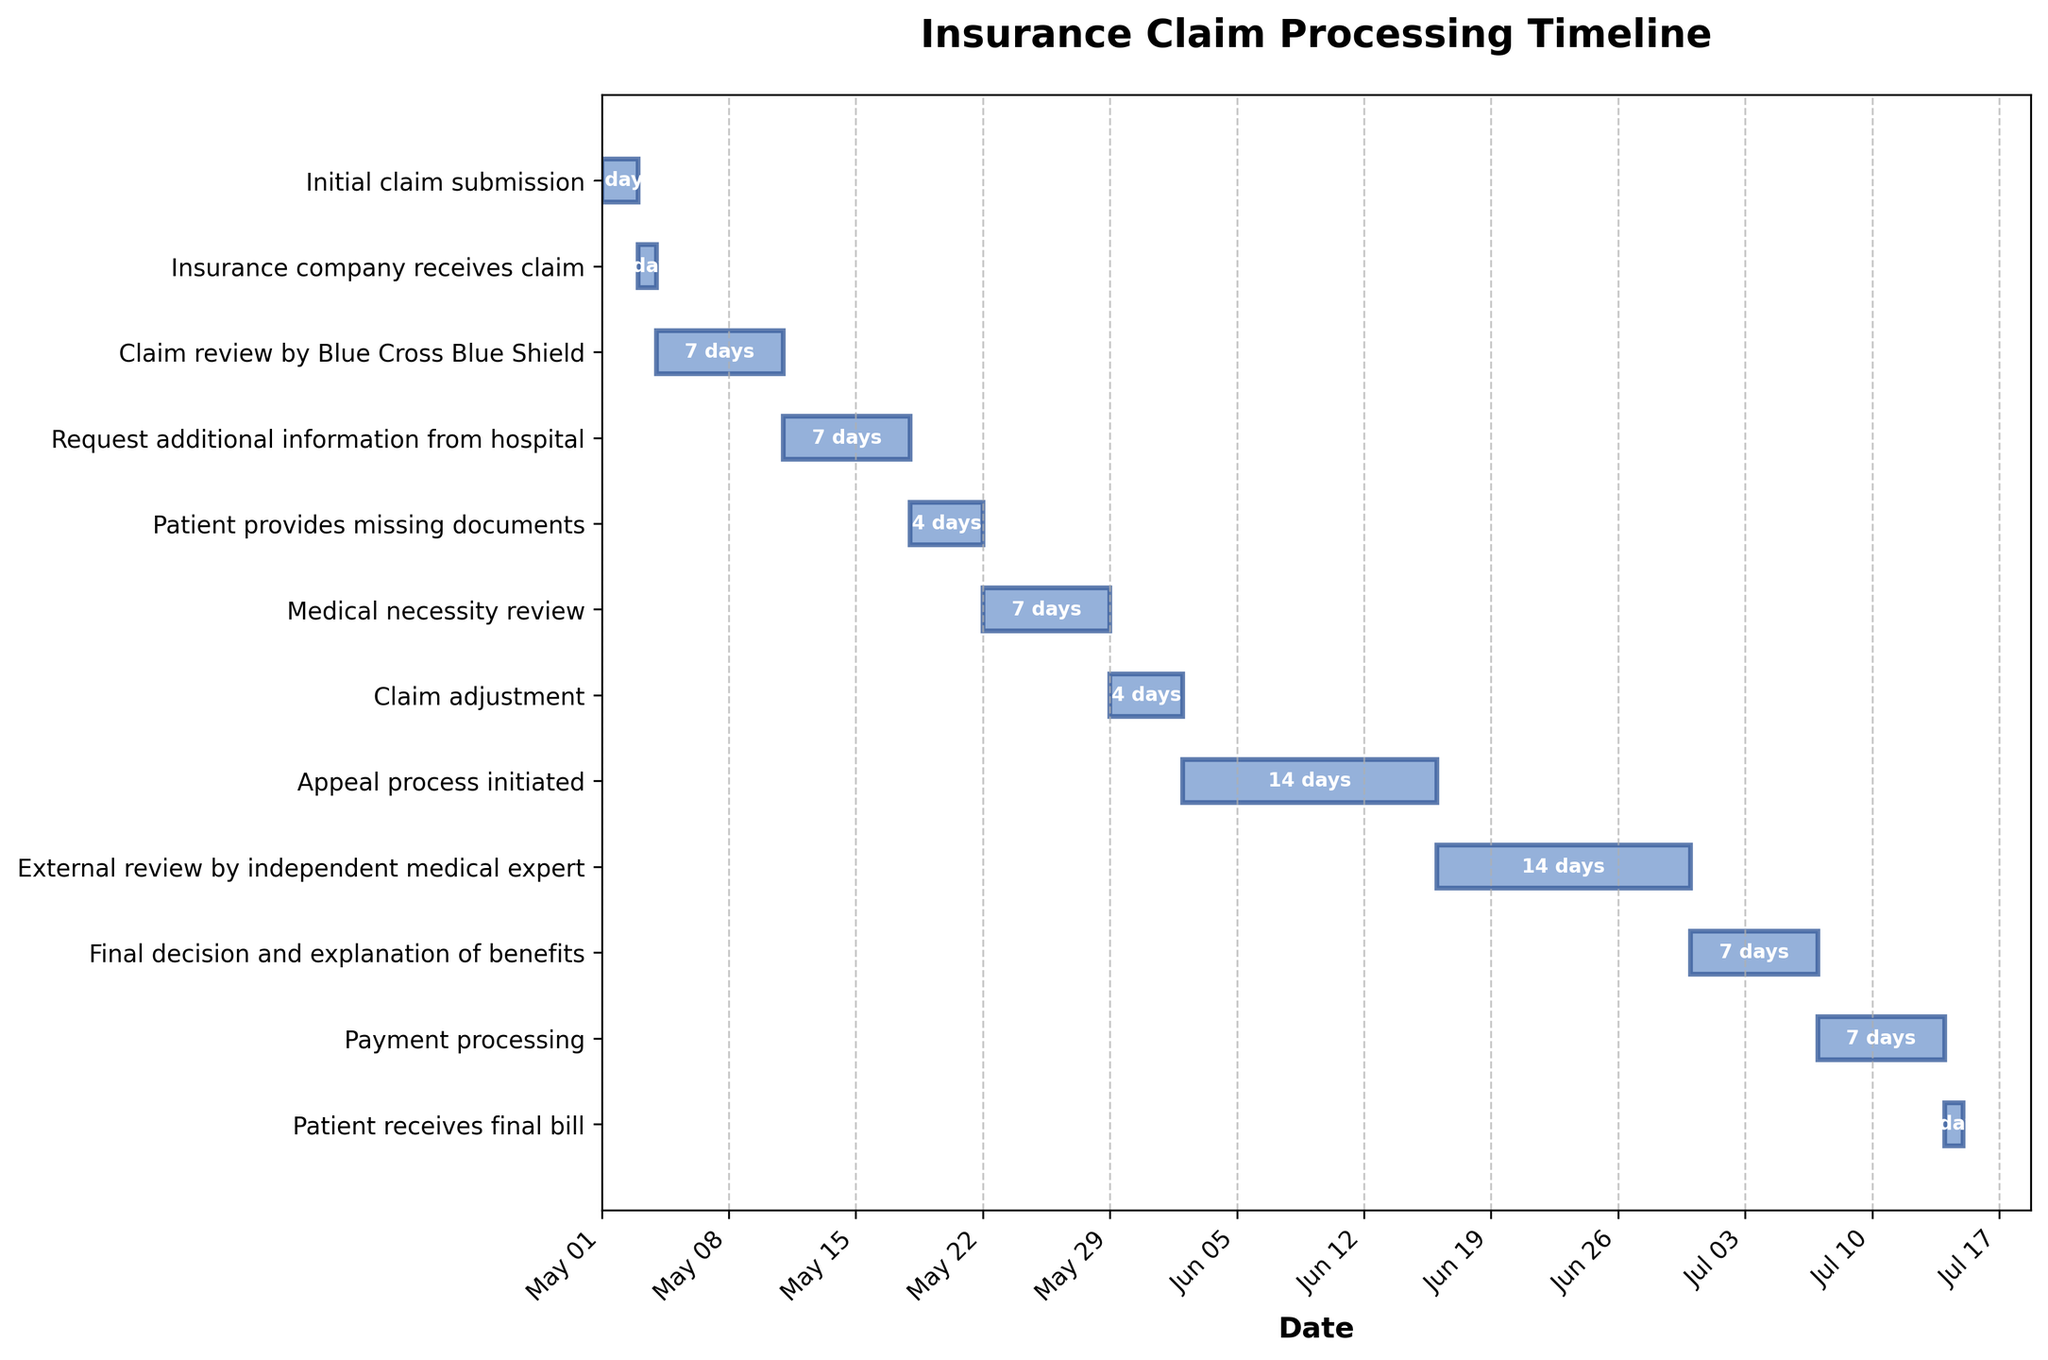What is the title of the figure? The title is usually displayed at the top of the plot and is designed to describe the subject of the graph. In this case, the title of the chart is located at the top center of the Gantt chart.
Answer: Insurance Claim Processing Timeline What is the duration of the 'Claim review by Blue Cross Blue Shield' stage? To determine the duration of this stage, look at the lengths of the bars in the Gantt chart corresponding to each task. The task 'Claim review by Blue Cross Blue Shield' has its start and end dates indicated, and the duration text is also placed on the bar.
Answer: 7 days Which stage took the longest to complete? Identify the stage with the longest horizontal bar on the Gantt chart. This stage will have the widest duration. Compare the lengths of all the bars to find the longest one.
Answer: Appeal process initiated Which stage ended on June 30, 2023? Look at the end dates indicated at the right end of each bar. Find the bar that ends on June 30, 2023.
Answer: External review by independent medical expert How many days did the 'Patient provides missing documents' stage take? Identify the 'Patient provides missing documents' bar on the Gantt chart. The duration will be indicated on the bar itself. This can also be verified by calculating the difference between the start and end dates for this stage.
Answer: 4 days What is the total duration from 'Initial claim submission' to 'Patient receives final bill'? Sum up the entire duration by adding the days from the start date of the first task to the end date of the last task, which can be visualized by observing the continuous flow of the Gantt chart.
Answer: 75 days Which two stages have the same duration of 4 days? Identify and compare the duration texts of all the bars in the Gantt chart to find two stages with equal lengths that indicate 4 days.
Answer: Patient provides missing documents, Payment processing How long did it take from the 'Medical necessity review' to the 'Appeal process initiated' stage? Calculate the days from the end of 'Medical necessity review' to the start of 'Appeal process initiated'. 'Medical necessity review' ends on May 29 and the 'Appeal process initiated' begins on June 2.
Answer: 4 days Which stage directly follows the 'Request additional information from hospital'? Look at the sequence of the stages in the Gantt chart. Identify the bar immediately following the bar for 'Request additional information from hospital'.
Answer: Patient provides missing documents 